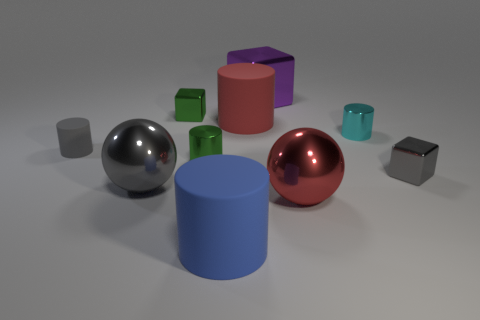Subtract all green cylinders. How many cylinders are left? 4 Subtract all cyan shiny cylinders. How many cylinders are left? 4 Subtract all brown cylinders. Subtract all purple spheres. How many cylinders are left? 5 Subtract all cubes. How many objects are left? 7 Subtract all small yellow metallic balls. Subtract all tiny cyan metallic objects. How many objects are left? 9 Add 1 small shiny things. How many small shiny things are left? 5 Add 6 large gray cubes. How many large gray cubes exist? 6 Subtract 0 brown cubes. How many objects are left? 10 